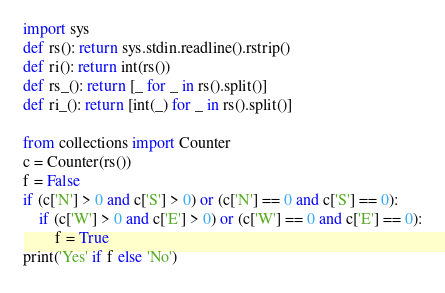Convert code to text. <code><loc_0><loc_0><loc_500><loc_500><_Python_>import sys
def rs(): return sys.stdin.readline().rstrip()
def ri(): return int(rs())
def rs_(): return [_ for _ in rs().split()]
def ri_(): return [int(_) for _ in rs().split()]

from collections import Counter
c = Counter(rs())
f = False
if (c['N'] > 0 and c['S'] > 0) or (c['N'] == 0 and c['S'] == 0):
    if (c['W'] > 0 and c['E'] > 0) or (c['W'] == 0 and c['E'] == 0):
        f = True
print('Yes' if f else 'No')</code> 